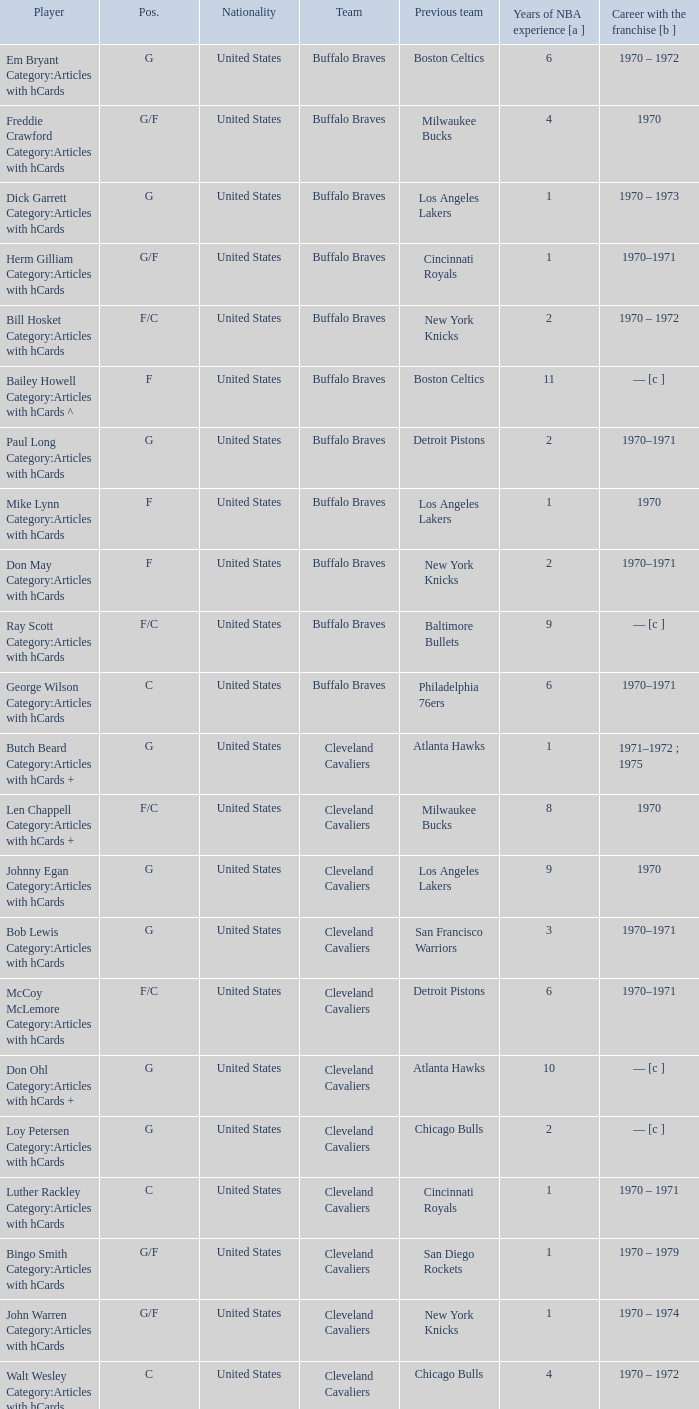Who is the buffalo braves' player that used to be part of the los angeles lakers and initiated their career with the organization in 1970? Mike Lynn Category:Articles with hCards. 